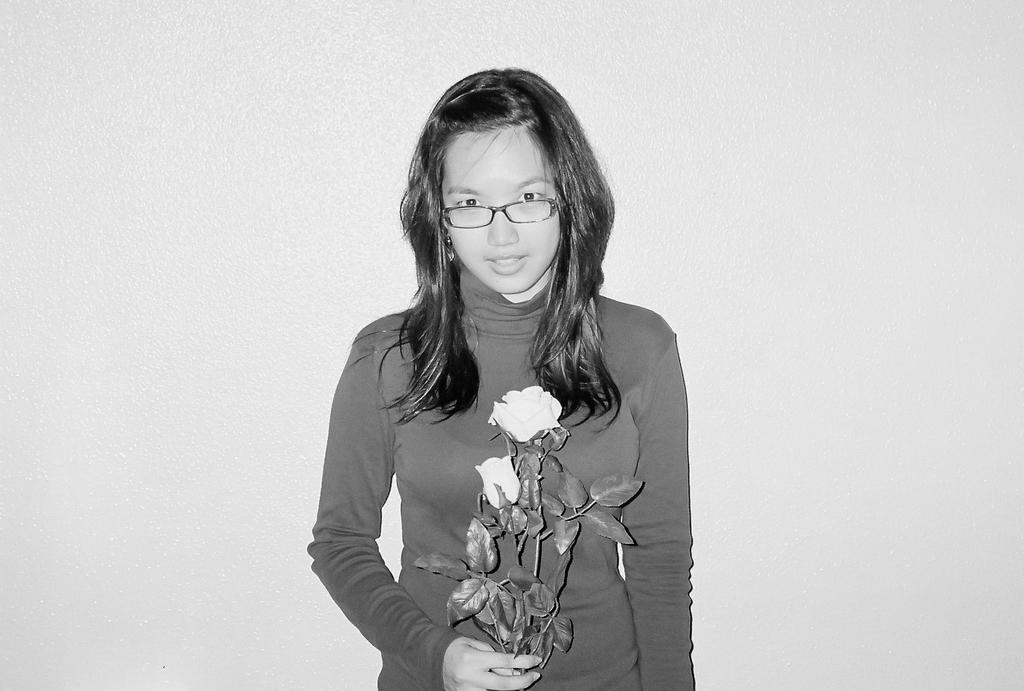What type of photograph is in the image? The image contains a black and white photograph. Who is the subject of the photograph? The photograph is of a girl. What is the girl wearing in the image? The girl is wearing a t-shirt. What is the girl holding in the photograph? The girl is holding a white flower in her hand. What is the background of the photograph? There is a white background in the image. What type of celery is the girl eating in the image? There is no celery present in the image; the girl is holding a white flower in her hand. What type of legal advice is the girl seeking in the image? There is no indication in the image that the girl is seeking legal advice or interacting with a lawyer. 